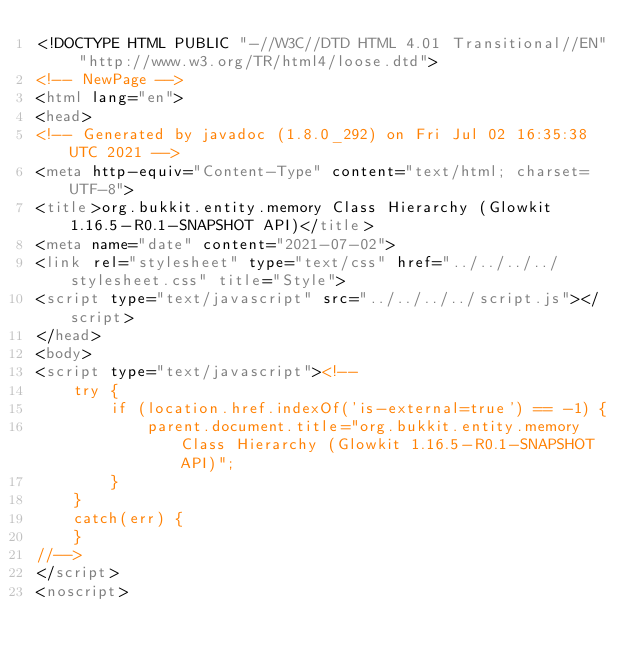<code> <loc_0><loc_0><loc_500><loc_500><_HTML_><!DOCTYPE HTML PUBLIC "-//W3C//DTD HTML 4.01 Transitional//EN" "http://www.w3.org/TR/html4/loose.dtd">
<!-- NewPage -->
<html lang="en">
<head>
<!-- Generated by javadoc (1.8.0_292) on Fri Jul 02 16:35:38 UTC 2021 -->
<meta http-equiv="Content-Type" content="text/html; charset=UTF-8">
<title>org.bukkit.entity.memory Class Hierarchy (Glowkit 1.16.5-R0.1-SNAPSHOT API)</title>
<meta name="date" content="2021-07-02">
<link rel="stylesheet" type="text/css" href="../../../../stylesheet.css" title="Style">
<script type="text/javascript" src="../../../../script.js"></script>
</head>
<body>
<script type="text/javascript"><!--
    try {
        if (location.href.indexOf('is-external=true') == -1) {
            parent.document.title="org.bukkit.entity.memory Class Hierarchy (Glowkit 1.16.5-R0.1-SNAPSHOT API)";
        }
    }
    catch(err) {
    }
//-->
</script>
<noscript></code> 